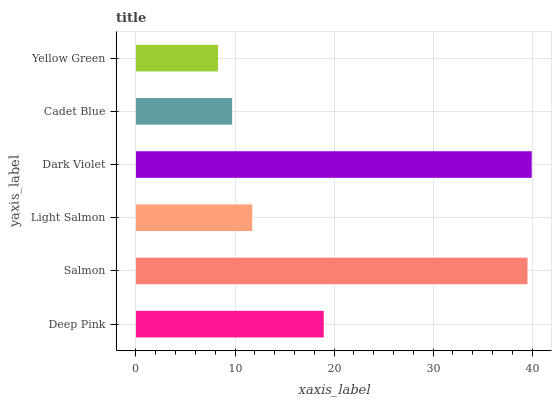Is Yellow Green the minimum?
Answer yes or no. Yes. Is Dark Violet the maximum?
Answer yes or no. Yes. Is Salmon the minimum?
Answer yes or no. No. Is Salmon the maximum?
Answer yes or no. No. Is Salmon greater than Deep Pink?
Answer yes or no. Yes. Is Deep Pink less than Salmon?
Answer yes or no. Yes. Is Deep Pink greater than Salmon?
Answer yes or no. No. Is Salmon less than Deep Pink?
Answer yes or no. No. Is Deep Pink the high median?
Answer yes or no. Yes. Is Light Salmon the low median?
Answer yes or no. Yes. Is Yellow Green the high median?
Answer yes or no. No. Is Deep Pink the low median?
Answer yes or no. No. 